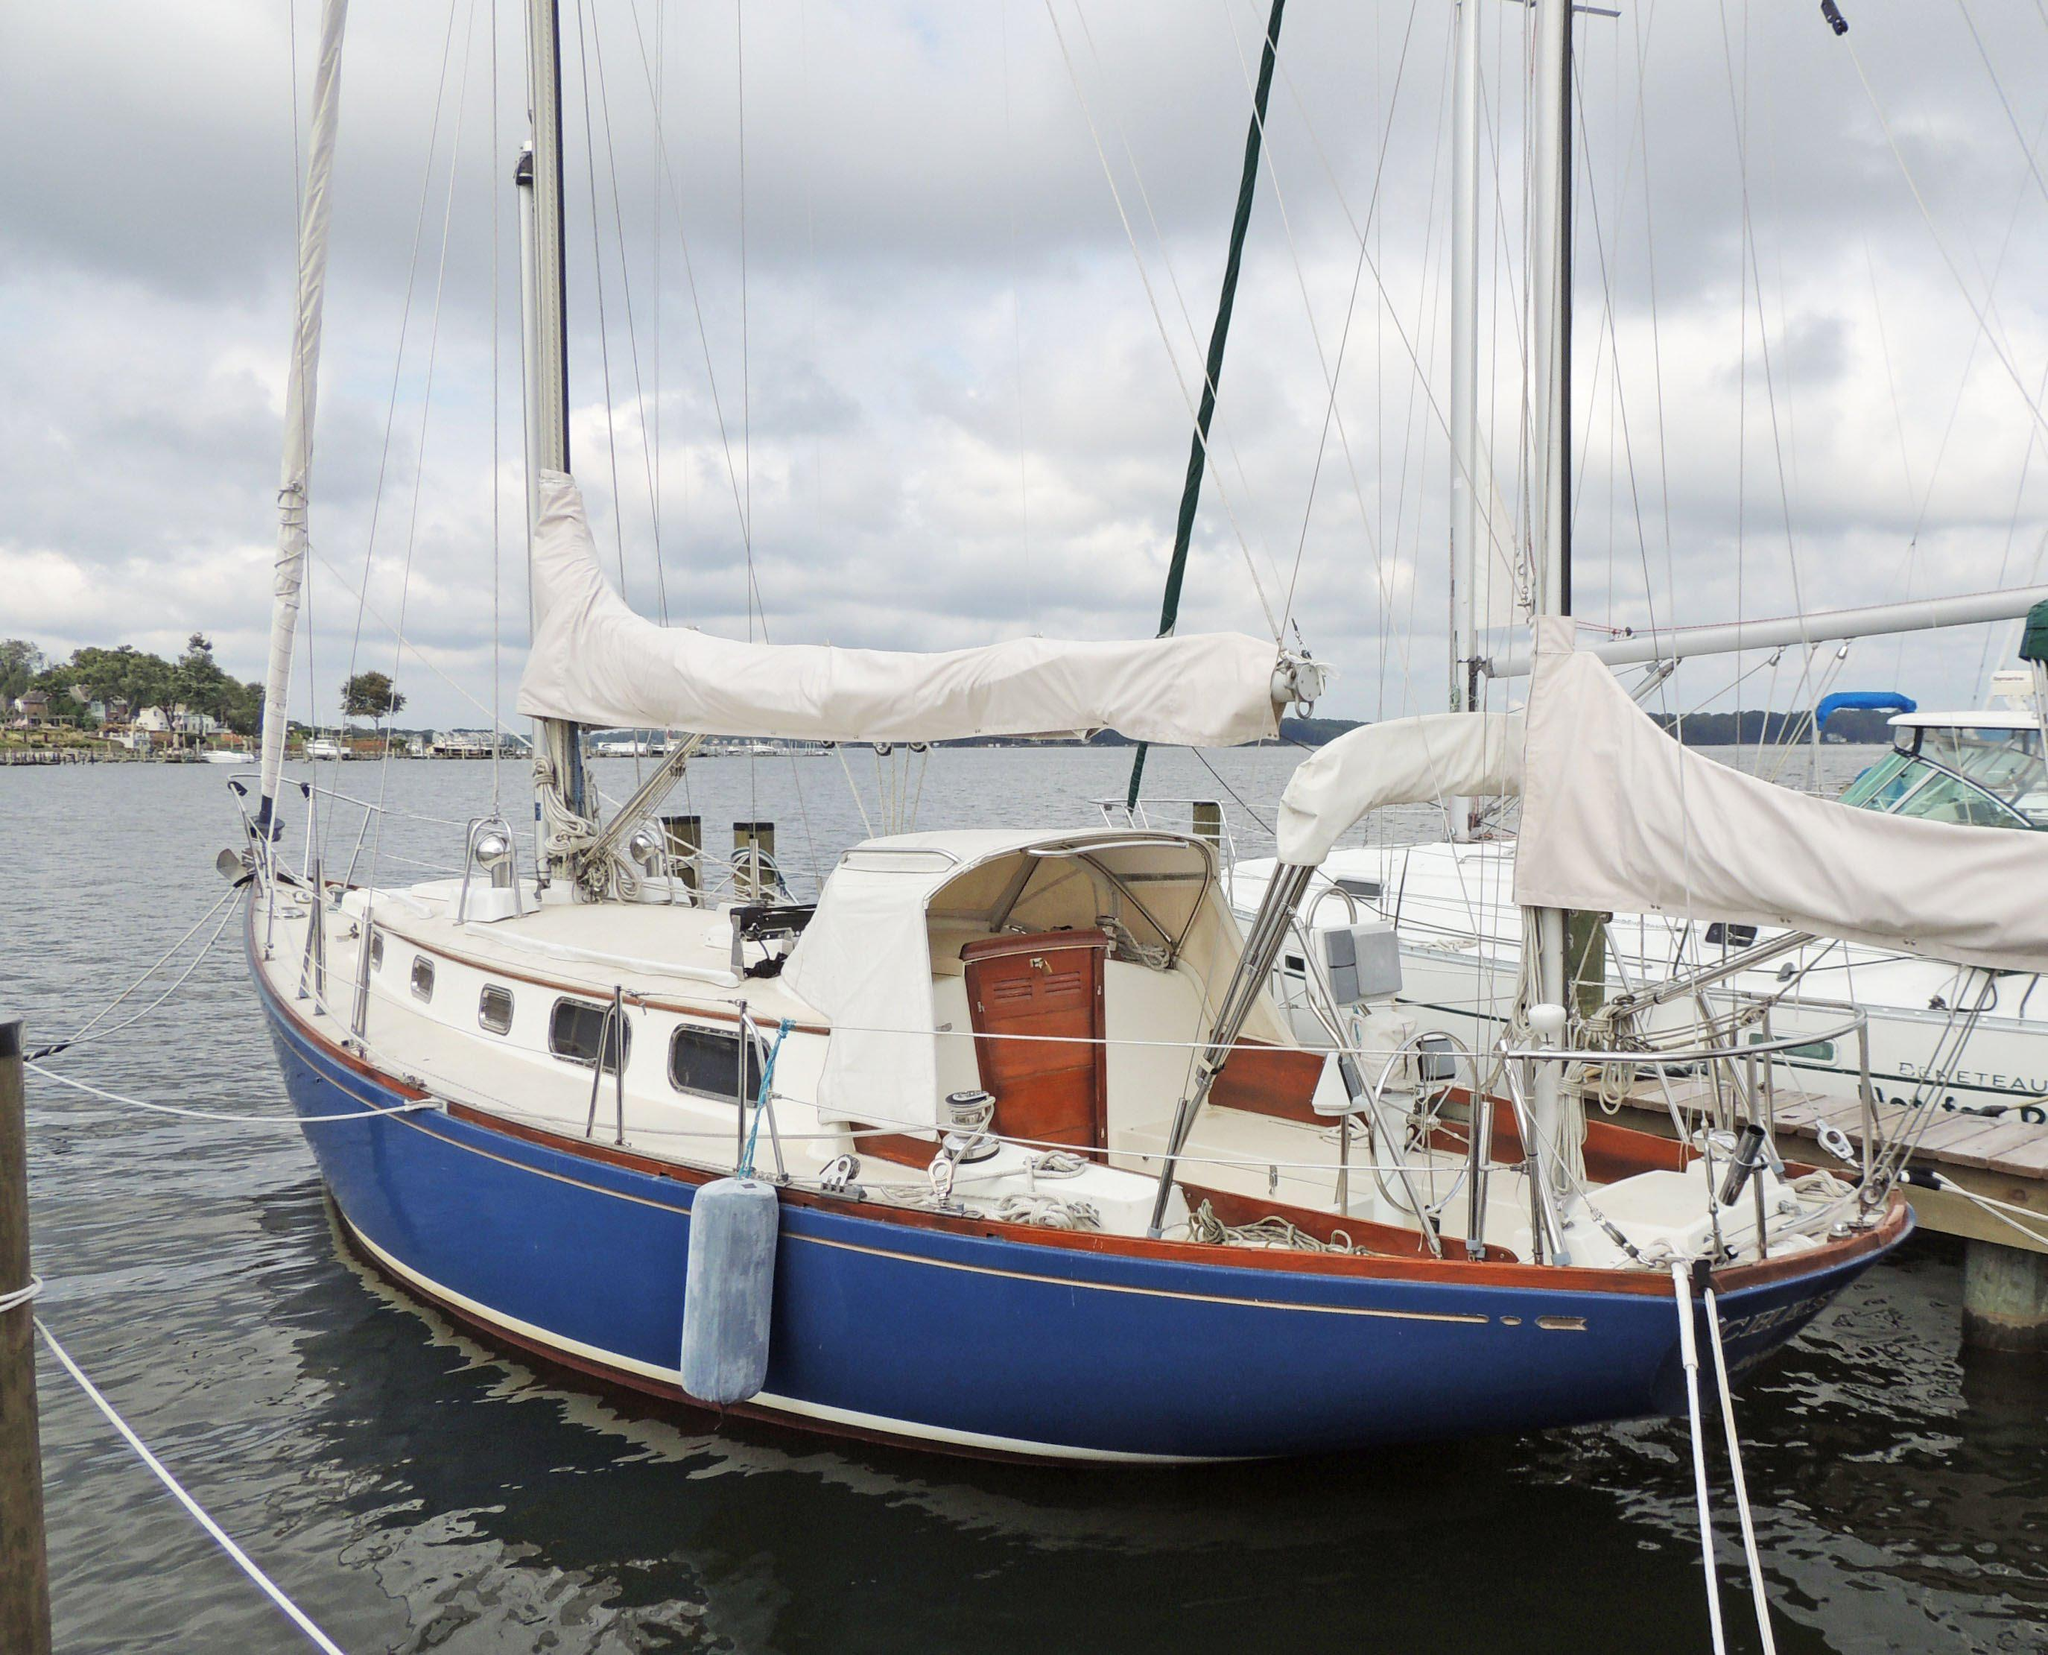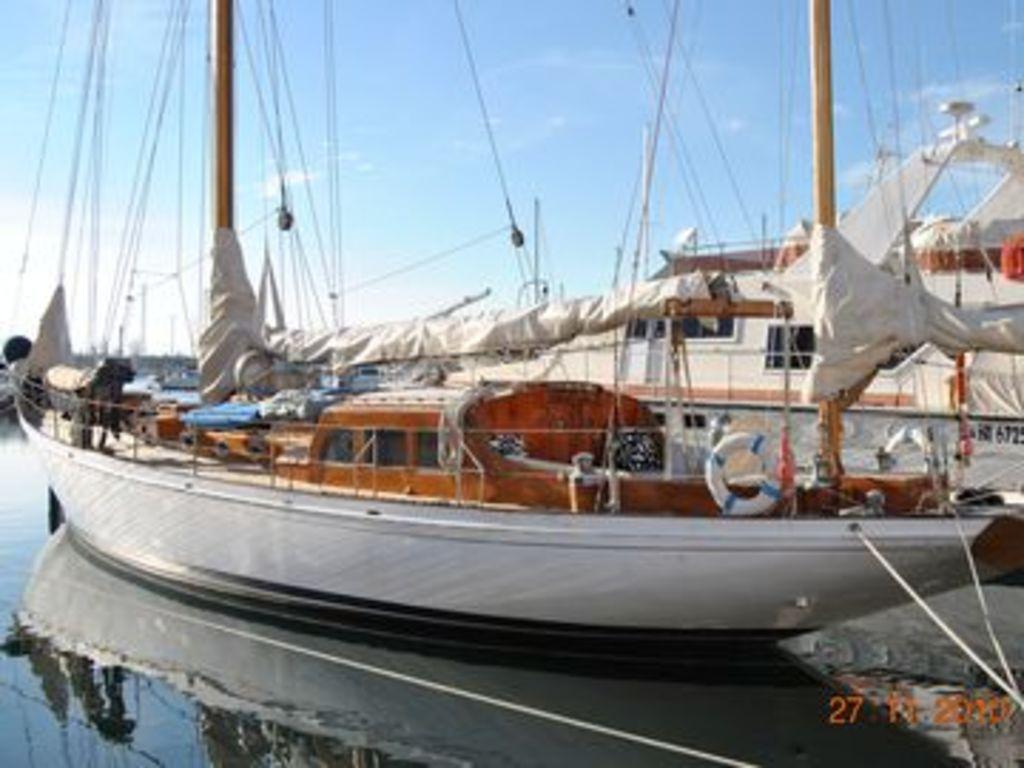The first image is the image on the left, the second image is the image on the right. Analyze the images presented: Is the assertion "One sailboat has its sails furled and the other has sails unfurled." valid? Answer yes or no. No. The first image is the image on the left, the second image is the image on the right. For the images shown, is this caption "One of the sailboats is blue." true? Answer yes or no. Yes. 